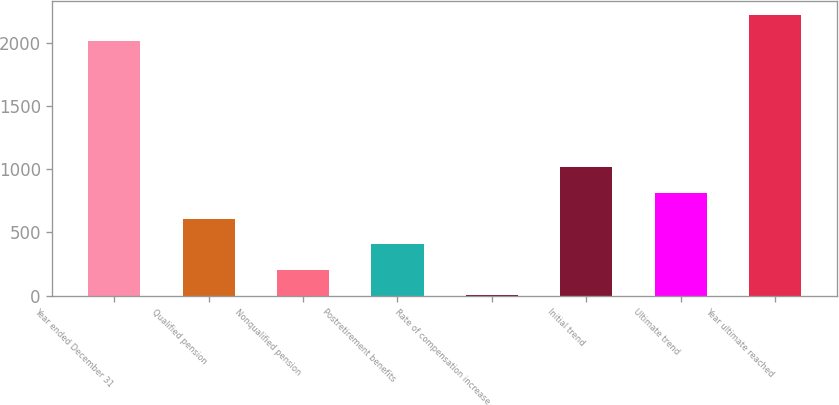<chart> <loc_0><loc_0><loc_500><loc_500><bar_chart><fcel>Year ended December 31<fcel>Qualified pension<fcel>Nonqualified pension<fcel>Postretirement benefits<fcel>Rate of compensation increase<fcel>Initial trend<fcel>Ultimate trend<fcel>Year ultimate reached<nl><fcel>2013<fcel>610.3<fcel>206.1<fcel>408.2<fcel>4<fcel>1014.5<fcel>812.4<fcel>2215.1<nl></chart> 